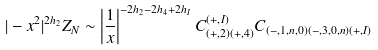<formula> <loc_0><loc_0><loc_500><loc_500>| - x ^ { 2 } | ^ { 2 h _ { 2 } } Z _ { N } \sim \left | \frac { 1 } { x } \right | ^ { - 2 h _ { 2 } - 2 h _ { 4 } + 2 h _ { I } } C _ { ( + , 2 ) ( + , 4 ) } ^ { ( + , I ) } C _ { ( - , 1 , n , 0 ) ( - , 3 , 0 , n ) ( + , I ) }</formula> 